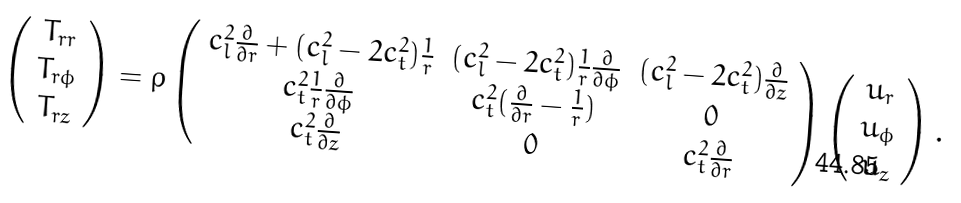Convert formula to latex. <formula><loc_0><loc_0><loc_500><loc_500>\left ( \begin{array} { c } T _ { r r } \\ T _ { r \phi } \\ T _ { r z } \end{array} \right ) = \rho \left ( \begin{array} { c c c } c _ { l } ^ { 2 } \frac { \partial } { \partial r } + ( c _ { l } ^ { 2 } - 2 c _ { t } ^ { 2 } ) \frac { 1 } { r } & ( c _ { l } ^ { 2 } - 2 c _ { t } ^ { 2 } ) \frac { 1 } { r } \frac { \partial } { \partial \phi } & ( c _ { l } ^ { 2 } - 2 c _ { t } ^ { 2 } ) \frac { \partial } { \partial z } \\ c _ { t } ^ { 2 } \frac { 1 } { r } \frac { \partial } { \partial \phi } & c _ { t } ^ { 2 } ( \frac { \partial } { \partial r } - \frac { 1 } { r } ) & 0 \\ c _ { t } ^ { 2 } \frac { \partial } { \partial z } & 0 & c _ { t } ^ { 2 } \frac { \partial } { \partial r } \end{array} \right ) \left ( \begin{array} { c } u _ { r } \\ u _ { \phi } \\ u _ { z } \end{array} \right ) .</formula> 